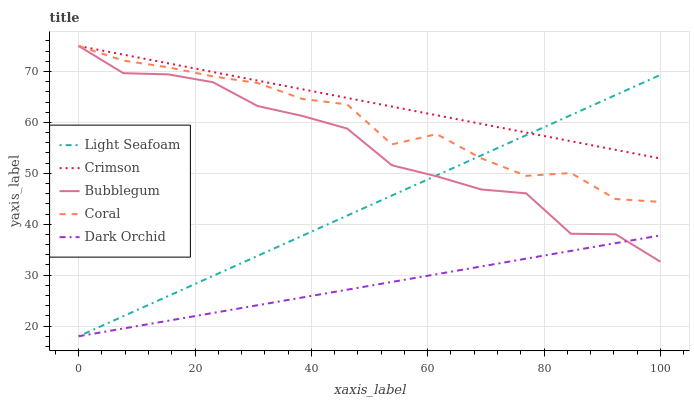Does Dark Orchid have the minimum area under the curve?
Answer yes or no. Yes. Does Crimson have the maximum area under the curve?
Answer yes or no. Yes. Does Coral have the minimum area under the curve?
Answer yes or no. No. Does Coral have the maximum area under the curve?
Answer yes or no. No. Is Light Seafoam the smoothest?
Answer yes or no. Yes. Is Coral the roughest?
Answer yes or no. Yes. Is Coral the smoothest?
Answer yes or no. No. Is Light Seafoam the roughest?
Answer yes or no. No. Does Light Seafoam have the lowest value?
Answer yes or no. Yes. Does Coral have the lowest value?
Answer yes or no. No. Does Bubblegum have the highest value?
Answer yes or no. Yes. Does Light Seafoam have the highest value?
Answer yes or no. No. Is Dark Orchid less than Crimson?
Answer yes or no. Yes. Is Crimson greater than Dark Orchid?
Answer yes or no. Yes. Does Crimson intersect Bubblegum?
Answer yes or no. Yes. Is Crimson less than Bubblegum?
Answer yes or no. No. Is Crimson greater than Bubblegum?
Answer yes or no. No. Does Dark Orchid intersect Crimson?
Answer yes or no. No. 